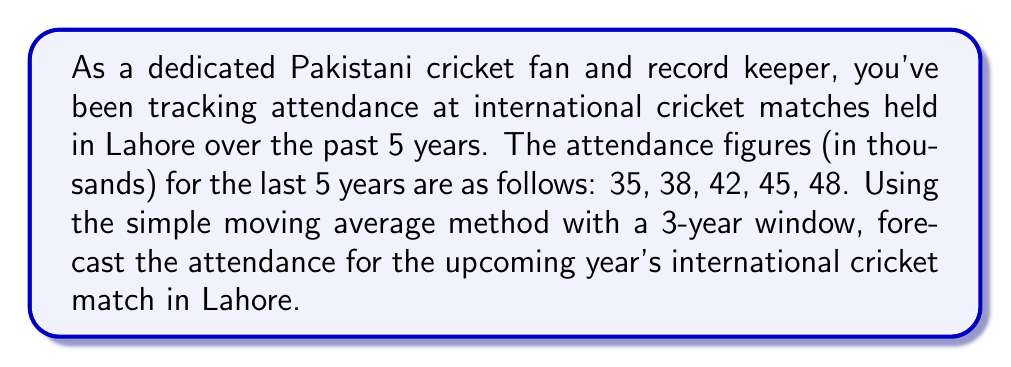Solve this math problem. To solve this problem, we'll use the simple moving average (SMA) method with a 3-year window. This method calculates the average of the most recent 3 years to forecast the next year's value.

Step 1: Identify the last 3 years of data
The last 3 years of attendance data are: 42, 45, 48 (in thousands)

Step 2: Calculate the simple moving average
The formula for SMA is:

$$ SMA = \frac{1}{n} \sum_{i=1}^{n} x_i $$

Where $n$ is the number of periods (in this case, 3), and $x_i$ are the values.

$$ SMA = \frac{1}{3} (42 + 45 + 48) $$
$$ SMA = \frac{1}{3} (135) $$
$$ SMA = 45 $$

Step 3: Interpret the result
The simple moving average forecast for the upcoming year's attendance is 45 thousand spectators.

This method assumes that the trend observed in the last three years will continue into the next year. It's worth noting that while this method is simple and easy to use, it doesn't account for more complex patterns or external factors that might influence attendance.
Answer: 45 thousand spectators 